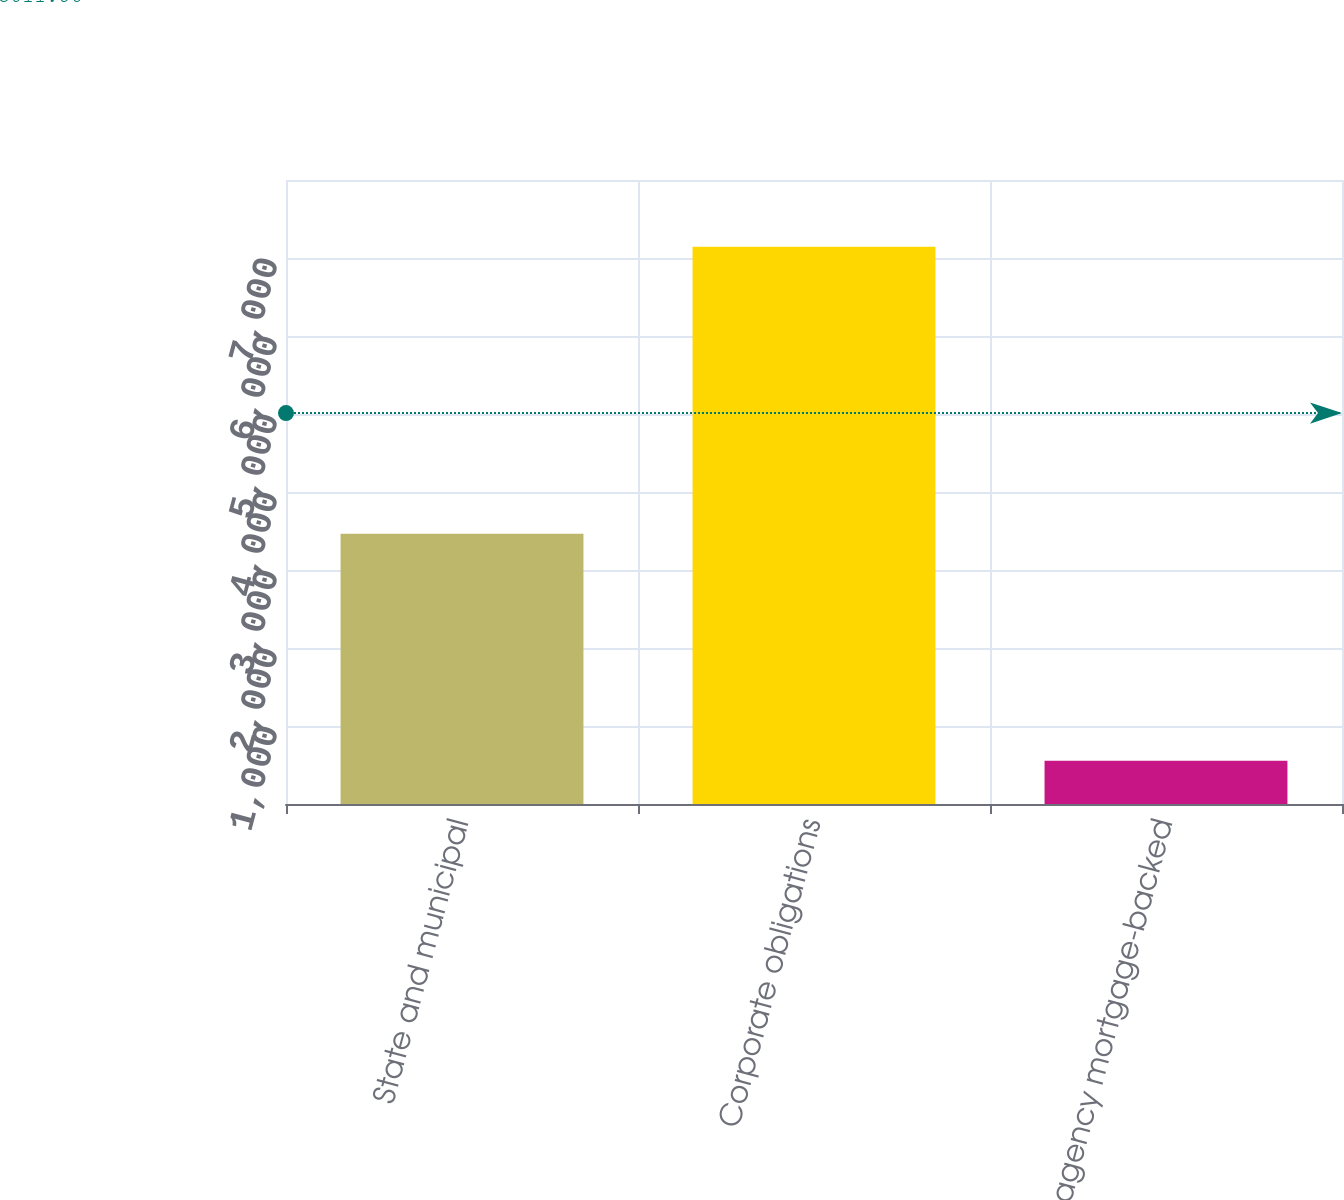<chart> <loc_0><loc_0><loc_500><loc_500><bar_chart><fcel>State and municipal<fcel>Corporate obligations<fcel>Non-US agency mortgage-backed<nl><fcel>3465<fcel>7143<fcel>555<nl></chart> 